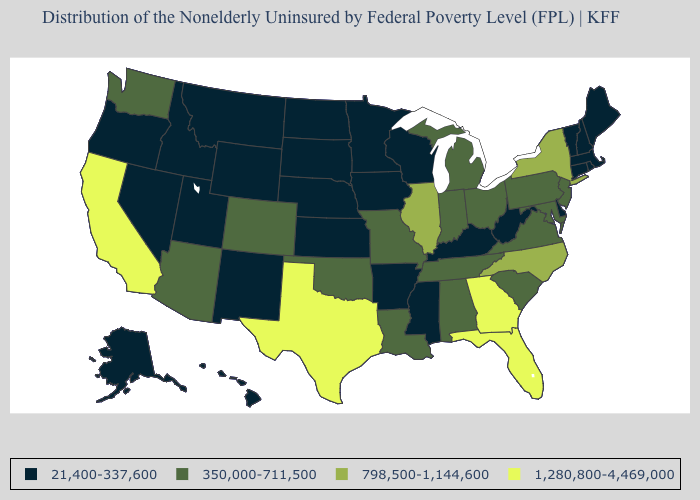What is the value of Kansas?
Quick response, please. 21,400-337,600. What is the value of Montana?
Short answer required. 21,400-337,600. What is the highest value in the USA?
Quick response, please. 1,280,800-4,469,000. What is the lowest value in the USA?
Quick response, please. 21,400-337,600. What is the value of Colorado?
Concise answer only. 350,000-711,500. Name the states that have a value in the range 21,400-337,600?
Be succinct. Alaska, Arkansas, Connecticut, Delaware, Hawaii, Idaho, Iowa, Kansas, Kentucky, Maine, Massachusetts, Minnesota, Mississippi, Montana, Nebraska, Nevada, New Hampshire, New Mexico, North Dakota, Oregon, Rhode Island, South Dakota, Utah, Vermont, West Virginia, Wisconsin, Wyoming. Name the states that have a value in the range 21,400-337,600?
Short answer required. Alaska, Arkansas, Connecticut, Delaware, Hawaii, Idaho, Iowa, Kansas, Kentucky, Maine, Massachusetts, Minnesota, Mississippi, Montana, Nebraska, Nevada, New Hampshire, New Mexico, North Dakota, Oregon, Rhode Island, South Dakota, Utah, Vermont, West Virginia, Wisconsin, Wyoming. Among the states that border Florida , which have the lowest value?
Concise answer only. Alabama. Is the legend a continuous bar?
Short answer required. No. Name the states that have a value in the range 1,280,800-4,469,000?
Answer briefly. California, Florida, Georgia, Texas. Does Kentucky have the lowest value in the South?
Concise answer only. Yes. Name the states that have a value in the range 21,400-337,600?
Quick response, please. Alaska, Arkansas, Connecticut, Delaware, Hawaii, Idaho, Iowa, Kansas, Kentucky, Maine, Massachusetts, Minnesota, Mississippi, Montana, Nebraska, Nevada, New Hampshire, New Mexico, North Dakota, Oregon, Rhode Island, South Dakota, Utah, Vermont, West Virginia, Wisconsin, Wyoming. Among the states that border Oklahoma , which have the lowest value?
Answer briefly. Arkansas, Kansas, New Mexico. Name the states that have a value in the range 350,000-711,500?
Be succinct. Alabama, Arizona, Colorado, Indiana, Louisiana, Maryland, Michigan, Missouri, New Jersey, Ohio, Oklahoma, Pennsylvania, South Carolina, Tennessee, Virginia, Washington. What is the highest value in the USA?
Concise answer only. 1,280,800-4,469,000. 